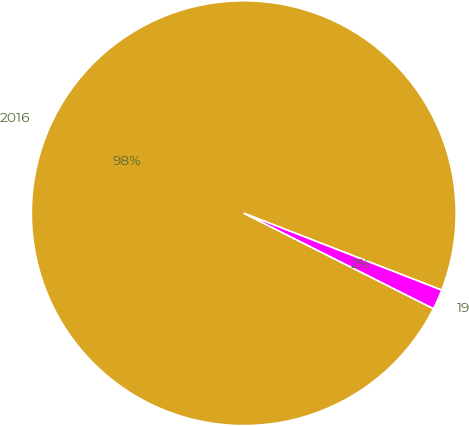Convert chart to OTSL. <chart><loc_0><loc_0><loc_500><loc_500><pie_chart><fcel>2016<fcel>19<nl><fcel>98.48%<fcel>1.52%<nl></chart> 